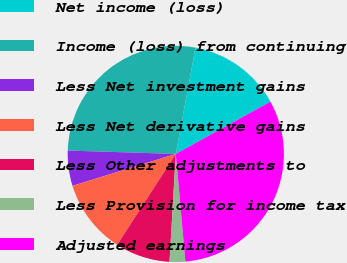<chart> <loc_0><loc_0><loc_500><loc_500><pie_chart><fcel>Net income (loss)<fcel>Income (loss) from continuing<fcel>Less Net investment gains<fcel>Less Net derivative gains<fcel>Less Other adjustments to<fcel>Less Provision for income tax<fcel>Adjusted earnings<nl><fcel>14.05%<fcel>27.42%<fcel>5.27%<fcel>11.12%<fcel>8.19%<fcel>2.34%<fcel>31.61%<nl></chart> 